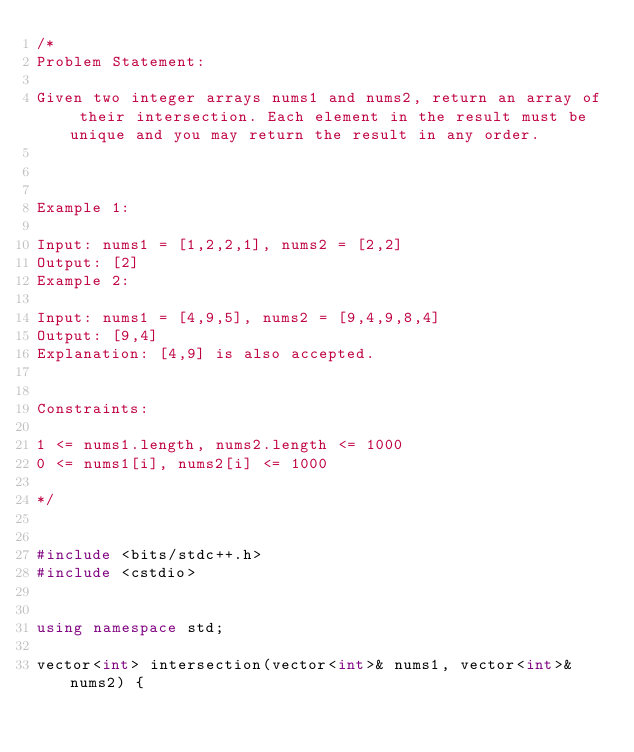<code> <loc_0><loc_0><loc_500><loc_500><_C++_>/*
Problem Statement:

Given two integer arrays nums1 and nums2, return an array of their intersection. Each element in the result must be unique and you may return the result in any order.



Example 1:

Input: nums1 = [1,2,2,1], nums2 = [2,2]
Output: [2]
Example 2:

Input: nums1 = [4,9,5], nums2 = [9,4,9,8,4]
Output: [9,4]
Explanation: [4,9] is also accepted.


Constraints:

1 <= nums1.length, nums2.length <= 1000
0 <= nums1[i], nums2[i] <= 1000

*/


#include <bits/stdc++.h>
#include <cstdio>


using namespace std;

vector<int> intersection(vector<int>& nums1, vector<int>& nums2) {
</code> 